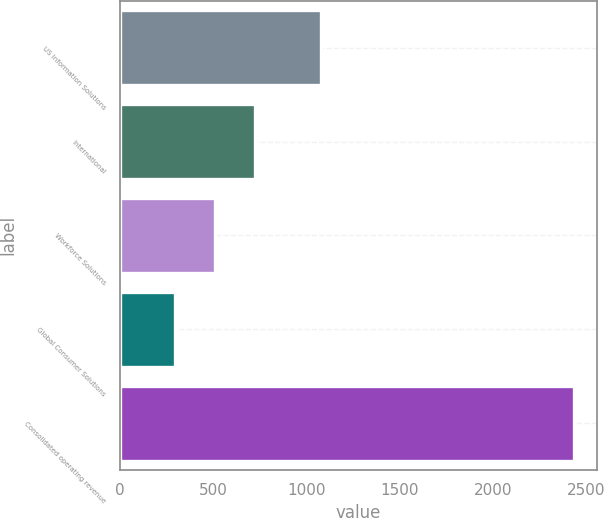Convert chart to OTSL. <chart><loc_0><loc_0><loc_500><loc_500><bar_chart><fcel>US Information Solutions<fcel>International<fcel>Workforce Solutions<fcel>Global Consumer Solutions<fcel>Consolidated operating revenue<nl><fcel>1079.9<fcel>722.64<fcel>508.42<fcel>294.2<fcel>2436.4<nl></chart> 